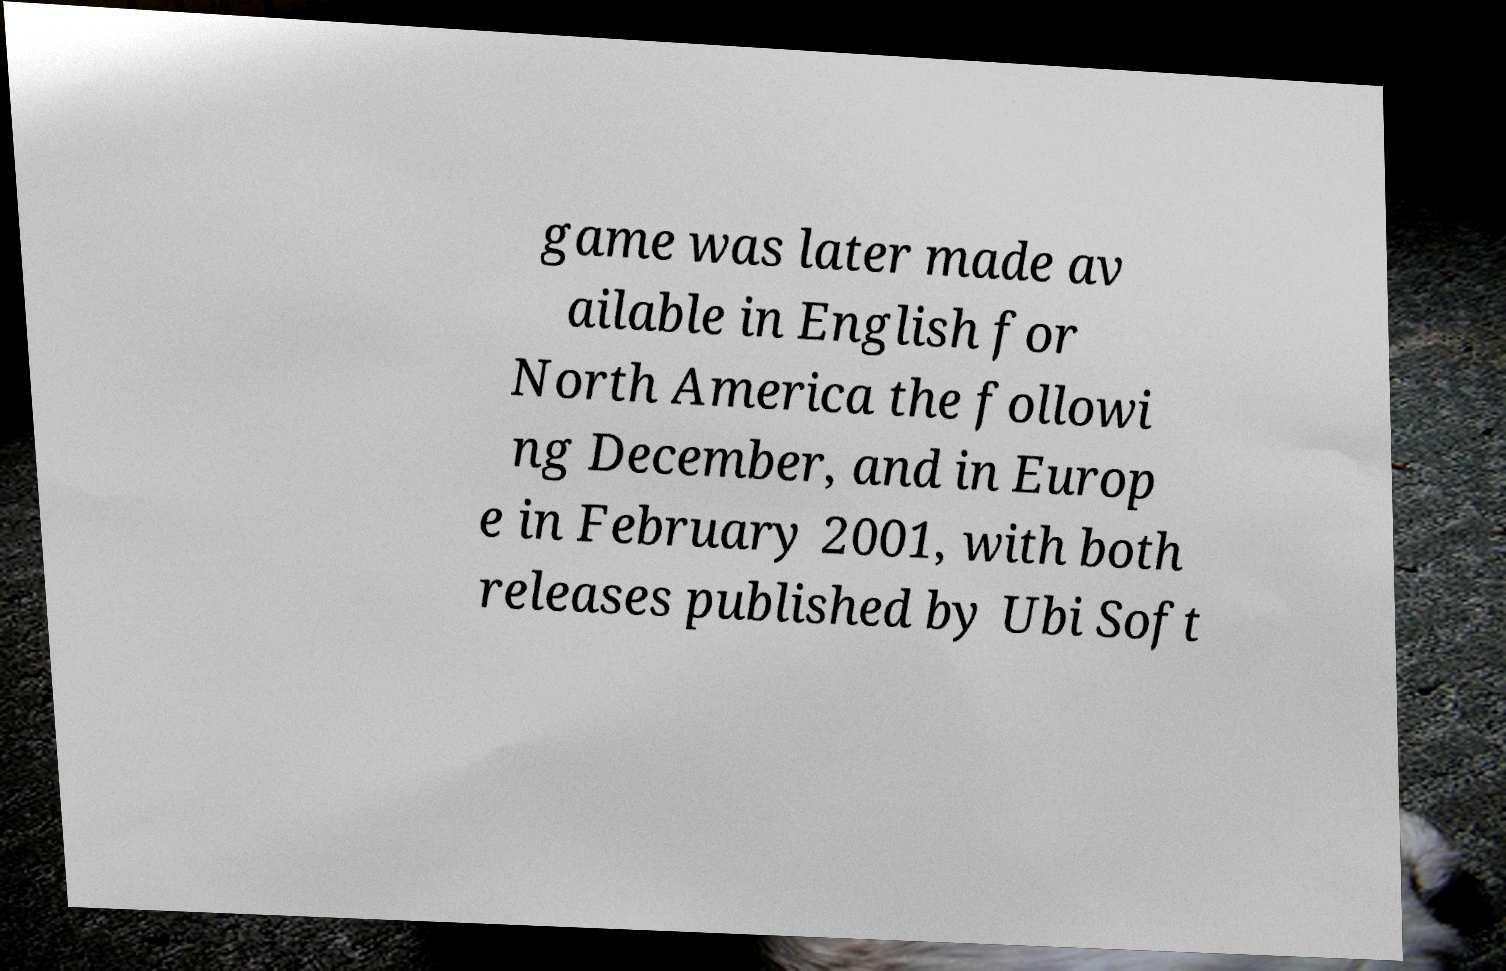Can you accurately transcribe the text from the provided image for me? game was later made av ailable in English for North America the followi ng December, and in Europ e in February 2001, with both releases published by Ubi Soft 